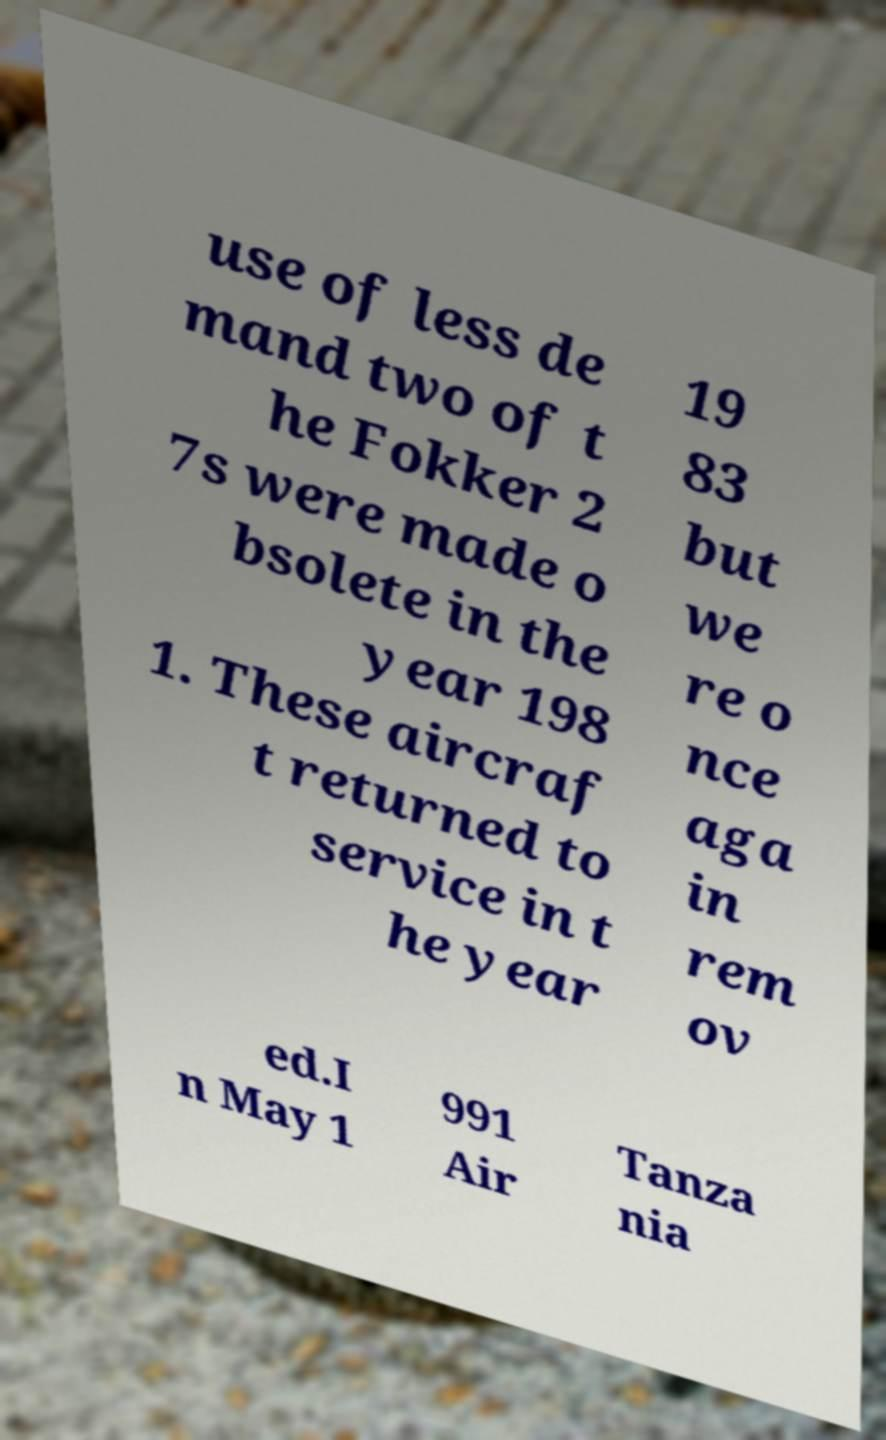Please identify and transcribe the text found in this image. use of less de mand two of t he Fokker 2 7s were made o bsolete in the year 198 1. These aircraf t returned to service in t he year 19 83 but we re o nce aga in rem ov ed.I n May 1 991 Air Tanza nia 